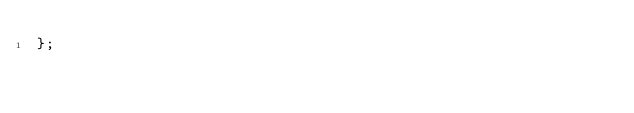<code> <loc_0><loc_0><loc_500><loc_500><_JavaScript_>};
</code> 